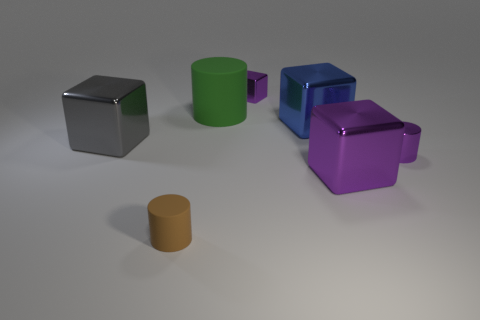Is the brown cylinder made of the same material as the large blue thing?
Give a very brief answer. No. How many yellow objects are either big objects or matte things?
Provide a succinct answer. 0. What number of small things are right of the small purple cube?
Your answer should be very brief. 1. Is the number of small gray matte things greater than the number of tiny cubes?
Give a very brief answer. No. There is a thing to the left of the small cylinder that is left of the big green rubber cylinder; what is its shape?
Offer a terse response. Cube. Does the metallic cylinder have the same color as the small cube?
Provide a succinct answer. Yes. Are there more gray metal objects in front of the big blue shiny object than large red rubber things?
Your answer should be compact. Yes. There is a tiny purple object behind the purple cylinder; how many tiny purple objects are on the left side of it?
Your response must be concise. 0. Is the material of the large cube in front of the big gray thing the same as the tiny object that is to the left of the green cylinder?
Ensure brevity in your answer.  No. What is the material of the tiny cube that is the same color as the metallic cylinder?
Offer a terse response. Metal. 